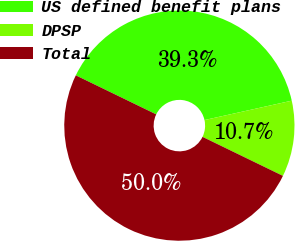<chart> <loc_0><loc_0><loc_500><loc_500><pie_chart><fcel>US defined benefit plans<fcel>DPSP<fcel>Total<nl><fcel>39.33%<fcel>10.67%<fcel>50.0%<nl></chart> 